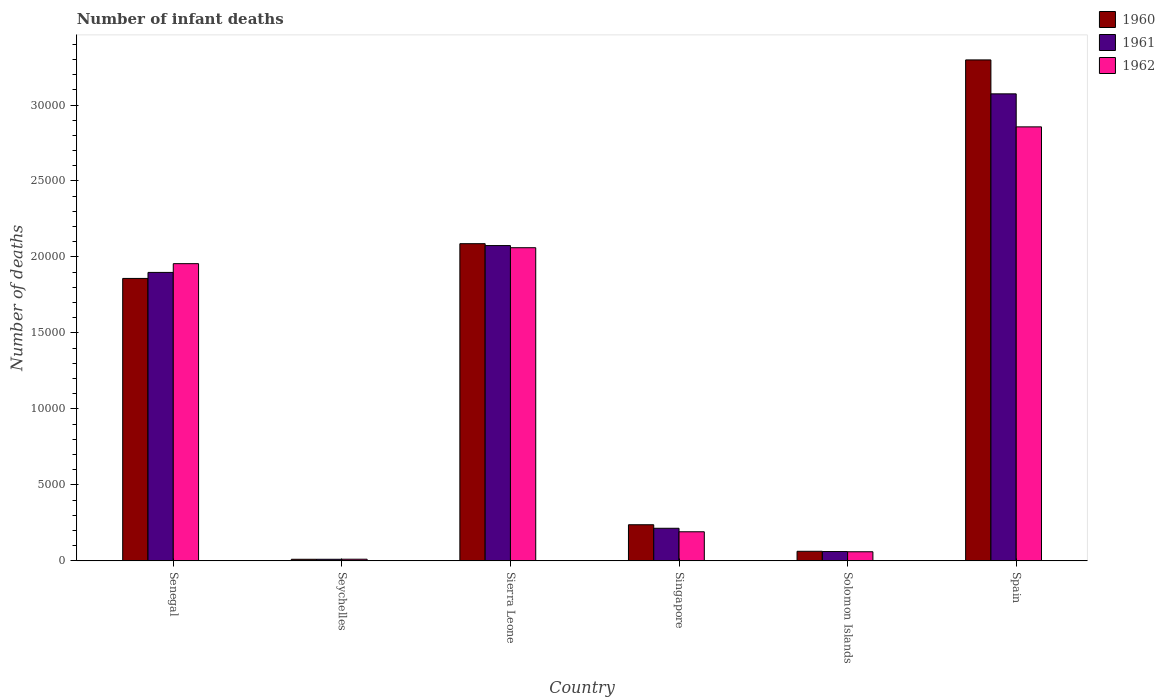How many groups of bars are there?
Offer a terse response. 6. How many bars are there on the 6th tick from the left?
Offer a very short reply. 3. How many bars are there on the 3rd tick from the right?
Your response must be concise. 3. What is the label of the 1st group of bars from the left?
Offer a terse response. Senegal. What is the number of infant deaths in 1962 in Senegal?
Ensure brevity in your answer.  1.96e+04. Across all countries, what is the maximum number of infant deaths in 1960?
Ensure brevity in your answer.  3.30e+04. Across all countries, what is the minimum number of infant deaths in 1960?
Keep it short and to the point. 102. In which country was the number of infant deaths in 1961 minimum?
Your answer should be very brief. Seychelles. What is the total number of infant deaths in 1961 in the graph?
Your answer should be very brief. 7.33e+04. What is the difference between the number of infant deaths in 1960 in Singapore and that in Spain?
Keep it short and to the point. -3.06e+04. What is the difference between the number of infant deaths in 1960 in Solomon Islands and the number of infant deaths in 1961 in Senegal?
Make the answer very short. -1.84e+04. What is the average number of infant deaths in 1962 per country?
Offer a very short reply. 1.19e+04. What is the difference between the number of infant deaths of/in 1961 and number of infant deaths of/in 1960 in Senegal?
Provide a short and direct response. 395. What is the ratio of the number of infant deaths in 1961 in Seychelles to that in Sierra Leone?
Offer a very short reply. 0. Is the number of infant deaths in 1961 in Sierra Leone less than that in Solomon Islands?
Keep it short and to the point. No. Is the difference between the number of infant deaths in 1961 in Sierra Leone and Singapore greater than the difference between the number of infant deaths in 1960 in Sierra Leone and Singapore?
Your answer should be compact. Yes. What is the difference between the highest and the second highest number of infant deaths in 1961?
Offer a very short reply. 1767. What is the difference between the highest and the lowest number of infant deaths in 1962?
Offer a terse response. 2.85e+04. What does the 1st bar from the right in Singapore represents?
Provide a short and direct response. 1962. How many bars are there?
Ensure brevity in your answer.  18. Are all the bars in the graph horizontal?
Keep it short and to the point. No. How many countries are there in the graph?
Your answer should be very brief. 6. Does the graph contain any zero values?
Provide a succinct answer. No. Does the graph contain grids?
Keep it short and to the point. No. Where does the legend appear in the graph?
Your answer should be compact. Top right. How many legend labels are there?
Offer a terse response. 3. How are the legend labels stacked?
Keep it short and to the point. Vertical. What is the title of the graph?
Ensure brevity in your answer.  Number of infant deaths. Does "1966" appear as one of the legend labels in the graph?
Provide a succinct answer. No. What is the label or title of the Y-axis?
Ensure brevity in your answer.  Number of deaths. What is the Number of deaths in 1960 in Senegal?
Make the answer very short. 1.86e+04. What is the Number of deaths of 1961 in Senegal?
Make the answer very short. 1.90e+04. What is the Number of deaths of 1962 in Senegal?
Make the answer very short. 1.96e+04. What is the Number of deaths of 1960 in Seychelles?
Your answer should be very brief. 102. What is the Number of deaths in 1961 in Seychelles?
Offer a terse response. 103. What is the Number of deaths in 1962 in Seychelles?
Your response must be concise. 107. What is the Number of deaths in 1960 in Sierra Leone?
Provide a short and direct response. 2.09e+04. What is the Number of deaths of 1961 in Sierra Leone?
Give a very brief answer. 2.07e+04. What is the Number of deaths of 1962 in Sierra Leone?
Your answer should be compact. 2.06e+04. What is the Number of deaths in 1960 in Singapore?
Your answer should be very brief. 2375. What is the Number of deaths of 1961 in Singapore?
Your response must be concise. 2143. What is the Number of deaths of 1962 in Singapore?
Give a very brief answer. 1912. What is the Number of deaths of 1960 in Solomon Islands?
Your answer should be very brief. 628. What is the Number of deaths in 1961 in Solomon Islands?
Provide a succinct answer. 612. What is the Number of deaths of 1962 in Solomon Islands?
Keep it short and to the point. 597. What is the Number of deaths of 1960 in Spain?
Your response must be concise. 3.30e+04. What is the Number of deaths of 1961 in Spain?
Provide a short and direct response. 3.07e+04. What is the Number of deaths of 1962 in Spain?
Give a very brief answer. 2.86e+04. Across all countries, what is the maximum Number of deaths in 1960?
Give a very brief answer. 3.30e+04. Across all countries, what is the maximum Number of deaths of 1961?
Make the answer very short. 3.07e+04. Across all countries, what is the maximum Number of deaths of 1962?
Offer a terse response. 2.86e+04. Across all countries, what is the minimum Number of deaths of 1960?
Give a very brief answer. 102. Across all countries, what is the minimum Number of deaths of 1961?
Keep it short and to the point. 103. Across all countries, what is the minimum Number of deaths in 1962?
Provide a short and direct response. 107. What is the total Number of deaths in 1960 in the graph?
Offer a very short reply. 7.55e+04. What is the total Number of deaths of 1961 in the graph?
Your answer should be compact. 7.33e+04. What is the total Number of deaths in 1962 in the graph?
Provide a short and direct response. 7.13e+04. What is the difference between the Number of deaths in 1960 in Senegal and that in Seychelles?
Your answer should be very brief. 1.85e+04. What is the difference between the Number of deaths in 1961 in Senegal and that in Seychelles?
Your answer should be compact. 1.89e+04. What is the difference between the Number of deaths in 1962 in Senegal and that in Seychelles?
Your answer should be compact. 1.95e+04. What is the difference between the Number of deaths in 1960 in Senegal and that in Sierra Leone?
Your answer should be compact. -2287. What is the difference between the Number of deaths in 1961 in Senegal and that in Sierra Leone?
Provide a short and direct response. -1767. What is the difference between the Number of deaths of 1962 in Senegal and that in Sierra Leone?
Offer a very short reply. -1050. What is the difference between the Number of deaths of 1960 in Senegal and that in Singapore?
Give a very brief answer. 1.62e+04. What is the difference between the Number of deaths in 1961 in Senegal and that in Singapore?
Keep it short and to the point. 1.68e+04. What is the difference between the Number of deaths of 1962 in Senegal and that in Singapore?
Offer a very short reply. 1.76e+04. What is the difference between the Number of deaths in 1960 in Senegal and that in Solomon Islands?
Keep it short and to the point. 1.80e+04. What is the difference between the Number of deaths in 1961 in Senegal and that in Solomon Islands?
Your response must be concise. 1.84e+04. What is the difference between the Number of deaths in 1962 in Senegal and that in Solomon Islands?
Offer a terse response. 1.90e+04. What is the difference between the Number of deaths in 1960 in Senegal and that in Spain?
Provide a short and direct response. -1.44e+04. What is the difference between the Number of deaths in 1961 in Senegal and that in Spain?
Your answer should be very brief. -1.18e+04. What is the difference between the Number of deaths in 1962 in Senegal and that in Spain?
Your response must be concise. -9004. What is the difference between the Number of deaths of 1960 in Seychelles and that in Sierra Leone?
Provide a short and direct response. -2.08e+04. What is the difference between the Number of deaths of 1961 in Seychelles and that in Sierra Leone?
Ensure brevity in your answer.  -2.06e+04. What is the difference between the Number of deaths in 1962 in Seychelles and that in Sierra Leone?
Your answer should be very brief. -2.05e+04. What is the difference between the Number of deaths of 1960 in Seychelles and that in Singapore?
Offer a terse response. -2273. What is the difference between the Number of deaths in 1961 in Seychelles and that in Singapore?
Ensure brevity in your answer.  -2040. What is the difference between the Number of deaths in 1962 in Seychelles and that in Singapore?
Keep it short and to the point. -1805. What is the difference between the Number of deaths of 1960 in Seychelles and that in Solomon Islands?
Ensure brevity in your answer.  -526. What is the difference between the Number of deaths in 1961 in Seychelles and that in Solomon Islands?
Offer a terse response. -509. What is the difference between the Number of deaths of 1962 in Seychelles and that in Solomon Islands?
Your answer should be very brief. -490. What is the difference between the Number of deaths in 1960 in Seychelles and that in Spain?
Your answer should be very brief. -3.29e+04. What is the difference between the Number of deaths in 1961 in Seychelles and that in Spain?
Offer a very short reply. -3.06e+04. What is the difference between the Number of deaths in 1962 in Seychelles and that in Spain?
Provide a short and direct response. -2.85e+04. What is the difference between the Number of deaths of 1960 in Sierra Leone and that in Singapore?
Ensure brevity in your answer.  1.85e+04. What is the difference between the Number of deaths of 1961 in Sierra Leone and that in Singapore?
Provide a short and direct response. 1.86e+04. What is the difference between the Number of deaths of 1962 in Sierra Leone and that in Singapore?
Offer a terse response. 1.87e+04. What is the difference between the Number of deaths in 1960 in Sierra Leone and that in Solomon Islands?
Make the answer very short. 2.02e+04. What is the difference between the Number of deaths of 1961 in Sierra Leone and that in Solomon Islands?
Your answer should be very brief. 2.01e+04. What is the difference between the Number of deaths of 1962 in Sierra Leone and that in Solomon Islands?
Make the answer very short. 2.00e+04. What is the difference between the Number of deaths in 1960 in Sierra Leone and that in Spain?
Offer a terse response. -1.21e+04. What is the difference between the Number of deaths of 1961 in Sierra Leone and that in Spain?
Your answer should be compact. -9986. What is the difference between the Number of deaths of 1962 in Sierra Leone and that in Spain?
Your answer should be very brief. -7954. What is the difference between the Number of deaths of 1960 in Singapore and that in Solomon Islands?
Give a very brief answer. 1747. What is the difference between the Number of deaths in 1961 in Singapore and that in Solomon Islands?
Offer a very short reply. 1531. What is the difference between the Number of deaths of 1962 in Singapore and that in Solomon Islands?
Keep it short and to the point. 1315. What is the difference between the Number of deaths of 1960 in Singapore and that in Spain?
Ensure brevity in your answer.  -3.06e+04. What is the difference between the Number of deaths of 1961 in Singapore and that in Spain?
Your response must be concise. -2.86e+04. What is the difference between the Number of deaths in 1962 in Singapore and that in Spain?
Offer a very short reply. -2.66e+04. What is the difference between the Number of deaths in 1960 in Solomon Islands and that in Spain?
Your answer should be compact. -3.23e+04. What is the difference between the Number of deaths in 1961 in Solomon Islands and that in Spain?
Your answer should be very brief. -3.01e+04. What is the difference between the Number of deaths in 1962 in Solomon Islands and that in Spain?
Offer a very short reply. -2.80e+04. What is the difference between the Number of deaths in 1960 in Senegal and the Number of deaths in 1961 in Seychelles?
Your answer should be compact. 1.85e+04. What is the difference between the Number of deaths of 1960 in Senegal and the Number of deaths of 1962 in Seychelles?
Your answer should be compact. 1.85e+04. What is the difference between the Number of deaths of 1961 in Senegal and the Number of deaths of 1962 in Seychelles?
Offer a very short reply. 1.89e+04. What is the difference between the Number of deaths in 1960 in Senegal and the Number of deaths in 1961 in Sierra Leone?
Give a very brief answer. -2162. What is the difference between the Number of deaths in 1960 in Senegal and the Number of deaths in 1962 in Sierra Leone?
Offer a terse response. -2021. What is the difference between the Number of deaths in 1961 in Senegal and the Number of deaths in 1962 in Sierra Leone?
Your answer should be very brief. -1626. What is the difference between the Number of deaths of 1960 in Senegal and the Number of deaths of 1961 in Singapore?
Your answer should be compact. 1.64e+04. What is the difference between the Number of deaths of 1960 in Senegal and the Number of deaths of 1962 in Singapore?
Your response must be concise. 1.67e+04. What is the difference between the Number of deaths of 1961 in Senegal and the Number of deaths of 1962 in Singapore?
Offer a terse response. 1.71e+04. What is the difference between the Number of deaths in 1960 in Senegal and the Number of deaths in 1961 in Solomon Islands?
Your answer should be very brief. 1.80e+04. What is the difference between the Number of deaths of 1960 in Senegal and the Number of deaths of 1962 in Solomon Islands?
Provide a succinct answer. 1.80e+04. What is the difference between the Number of deaths in 1961 in Senegal and the Number of deaths in 1962 in Solomon Islands?
Provide a succinct answer. 1.84e+04. What is the difference between the Number of deaths in 1960 in Senegal and the Number of deaths in 1961 in Spain?
Give a very brief answer. -1.21e+04. What is the difference between the Number of deaths in 1960 in Senegal and the Number of deaths in 1962 in Spain?
Offer a very short reply. -9975. What is the difference between the Number of deaths of 1961 in Senegal and the Number of deaths of 1962 in Spain?
Keep it short and to the point. -9580. What is the difference between the Number of deaths of 1960 in Seychelles and the Number of deaths of 1961 in Sierra Leone?
Your response must be concise. -2.06e+04. What is the difference between the Number of deaths of 1960 in Seychelles and the Number of deaths of 1962 in Sierra Leone?
Ensure brevity in your answer.  -2.05e+04. What is the difference between the Number of deaths of 1961 in Seychelles and the Number of deaths of 1962 in Sierra Leone?
Offer a terse response. -2.05e+04. What is the difference between the Number of deaths in 1960 in Seychelles and the Number of deaths in 1961 in Singapore?
Provide a succinct answer. -2041. What is the difference between the Number of deaths of 1960 in Seychelles and the Number of deaths of 1962 in Singapore?
Offer a terse response. -1810. What is the difference between the Number of deaths in 1961 in Seychelles and the Number of deaths in 1962 in Singapore?
Your response must be concise. -1809. What is the difference between the Number of deaths in 1960 in Seychelles and the Number of deaths in 1961 in Solomon Islands?
Your answer should be compact. -510. What is the difference between the Number of deaths of 1960 in Seychelles and the Number of deaths of 1962 in Solomon Islands?
Keep it short and to the point. -495. What is the difference between the Number of deaths in 1961 in Seychelles and the Number of deaths in 1962 in Solomon Islands?
Your answer should be very brief. -494. What is the difference between the Number of deaths of 1960 in Seychelles and the Number of deaths of 1961 in Spain?
Your response must be concise. -3.06e+04. What is the difference between the Number of deaths of 1960 in Seychelles and the Number of deaths of 1962 in Spain?
Your response must be concise. -2.85e+04. What is the difference between the Number of deaths in 1961 in Seychelles and the Number of deaths in 1962 in Spain?
Give a very brief answer. -2.85e+04. What is the difference between the Number of deaths in 1960 in Sierra Leone and the Number of deaths in 1961 in Singapore?
Keep it short and to the point. 1.87e+04. What is the difference between the Number of deaths of 1960 in Sierra Leone and the Number of deaths of 1962 in Singapore?
Provide a short and direct response. 1.90e+04. What is the difference between the Number of deaths in 1961 in Sierra Leone and the Number of deaths in 1962 in Singapore?
Give a very brief answer. 1.88e+04. What is the difference between the Number of deaths in 1960 in Sierra Leone and the Number of deaths in 1961 in Solomon Islands?
Provide a short and direct response. 2.03e+04. What is the difference between the Number of deaths in 1960 in Sierra Leone and the Number of deaths in 1962 in Solomon Islands?
Keep it short and to the point. 2.03e+04. What is the difference between the Number of deaths of 1961 in Sierra Leone and the Number of deaths of 1962 in Solomon Islands?
Your answer should be very brief. 2.02e+04. What is the difference between the Number of deaths of 1960 in Sierra Leone and the Number of deaths of 1961 in Spain?
Your response must be concise. -9861. What is the difference between the Number of deaths of 1960 in Sierra Leone and the Number of deaths of 1962 in Spain?
Provide a short and direct response. -7688. What is the difference between the Number of deaths in 1961 in Sierra Leone and the Number of deaths in 1962 in Spain?
Ensure brevity in your answer.  -7813. What is the difference between the Number of deaths in 1960 in Singapore and the Number of deaths in 1961 in Solomon Islands?
Provide a short and direct response. 1763. What is the difference between the Number of deaths of 1960 in Singapore and the Number of deaths of 1962 in Solomon Islands?
Your response must be concise. 1778. What is the difference between the Number of deaths in 1961 in Singapore and the Number of deaths in 1962 in Solomon Islands?
Your answer should be compact. 1546. What is the difference between the Number of deaths in 1960 in Singapore and the Number of deaths in 1961 in Spain?
Give a very brief answer. -2.84e+04. What is the difference between the Number of deaths in 1960 in Singapore and the Number of deaths in 1962 in Spain?
Provide a succinct answer. -2.62e+04. What is the difference between the Number of deaths of 1961 in Singapore and the Number of deaths of 1962 in Spain?
Provide a succinct answer. -2.64e+04. What is the difference between the Number of deaths of 1960 in Solomon Islands and the Number of deaths of 1961 in Spain?
Keep it short and to the point. -3.01e+04. What is the difference between the Number of deaths in 1960 in Solomon Islands and the Number of deaths in 1962 in Spain?
Provide a succinct answer. -2.79e+04. What is the difference between the Number of deaths in 1961 in Solomon Islands and the Number of deaths in 1962 in Spain?
Your answer should be very brief. -2.80e+04. What is the average Number of deaths of 1960 per country?
Give a very brief answer. 1.26e+04. What is the average Number of deaths of 1961 per country?
Your response must be concise. 1.22e+04. What is the average Number of deaths in 1962 per country?
Your response must be concise. 1.19e+04. What is the difference between the Number of deaths of 1960 and Number of deaths of 1961 in Senegal?
Your answer should be very brief. -395. What is the difference between the Number of deaths of 1960 and Number of deaths of 1962 in Senegal?
Provide a short and direct response. -971. What is the difference between the Number of deaths of 1961 and Number of deaths of 1962 in Senegal?
Your answer should be very brief. -576. What is the difference between the Number of deaths in 1960 and Number of deaths in 1961 in Sierra Leone?
Offer a terse response. 125. What is the difference between the Number of deaths in 1960 and Number of deaths in 1962 in Sierra Leone?
Your answer should be very brief. 266. What is the difference between the Number of deaths of 1961 and Number of deaths of 1962 in Sierra Leone?
Make the answer very short. 141. What is the difference between the Number of deaths of 1960 and Number of deaths of 1961 in Singapore?
Your answer should be compact. 232. What is the difference between the Number of deaths in 1960 and Number of deaths in 1962 in Singapore?
Make the answer very short. 463. What is the difference between the Number of deaths in 1961 and Number of deaths in 1962 in Singapore?
Give a very brief answer. 231. What is the difference between the Number of deaths in 1960 and Number of deaths in 1962 in Solomon Islands?
Your answer should be compact. 31. What is the difference between the Number of deaths of 1960 and Number of deaths of 1961 in Spain?
Your answer should be very brief. 2233. What is the difference between the Number of deaths of 1960 and Number of deaths of 1962 in Spain?
Give a very brief answer. 4406. What is the difference between the Number of deaths of 1961 and Number of deaths of 1962 in Spain?
Your answer should be very brief. 2173. What is the ratio of the Number of deaths in 1960 in Senegal to that in Seychelles?
Your answer should be compact. 182.23. What is the ratio of the Number of deaths in 1961 in Senegal to that in Seychelles?
Offer a terse response. 184.29. What is the ratio of the Number of deaths in 1962 in Senegal to that in Seychelles?
Your response must be concise. 182.78. What is the ratio of the Number of deaths in 1960 in Senegal to that in Sierra Leone?
Provide a succinct answer. 0.89. What is the ratio of the Number of deaths in 1961 in Senegal to that in Sierra Leone?
Keep it short and to the point. 0.91. What is the ratio of the Number of deaths of 1962 in Senegal to that in Sierra Leone?
Provide a succinct answer. 0.95. What is the ratio of the Number of deaths of 1960 in Senegal to that in Singapore?
Offer a very short reply. 7.83. What is the ratio of the Number of deaths of 1961 in Senegal to that in Singapore?
Your answer should be compact. 8.86. What is the ratio of the Number of deaths of 1962 in Senegal to that in Singapore?
Provide a succinct answer. 10.23. What is the ratio of the Number of deaths of 1960 in Senegal to that in Solomon Islands?
Give a very brief answer. 29.6. What is the ratio of the Number of deaths in 1961 in Senegal to that in Solomon Islands?
Provide a succinct answer. 31.02. What is the ratio of the Number of deaths in 1962 in Senegal to that in Solomon Islands?
Your response must be concise. 32.76. What is the ratio of the Number of deaths of 1960 in Senegal to that in Spain?
Your response must be concise. 0.56. What is the ratio of the Number of deaths in 1961 in Senegal to that in Spain?
Give a very brief answer. 0.62. What is the ratio of the Number of deaths of 1962 in Senegal to that in Spain?
Make the answer very short. 0.68. What is the ratio of the Number of deaths of 1960 in Seychelles to that in Sierra Leone?
Offer a very short reply. 0. What is the ratio of the Number of deaths in 1961 in Seychelles to that in Sierra Leone?
Offer a very short reply. 0.01. What is the ratio of the Number of deaths of 1962 in Seychelles to that in Sierra Leone?
Provide a succinct answer. 0.01. What is the ratio of the Number of deaths of 1960 in Seychelles to that in Singapore?
Ensure brevity in your answer.  0.04. What is the ratio of the Number of deaths of 1961 in Seychelles to that in Singapore?
Your response must be concise. 0.05. What is the ratio of the Number of deaths of 1962 in Seychelles to that in Singapore?
Provide a short and direct response. 0.06. What is the ratio of the Number of deaths of 1960 in Seychelles to that in Solomon Islands?
Your answer should be very brief. 0.16. What is the ratio of the Number of deaths in 1961 in Seychelles to that in Solomon Islands?
Ensure brevity in your answer.  0.17. What is the ratio of the Number of deaths of 1962 in Seychelles to that in Solomon Islands?
Make the answer very short. 0.18. What is the ratio of the Number of deaths of 1960 in Seychelles to that in Spain?
Provide a succinct answer. 0. What is the ratio of the Number of deaths in 1961 in Seychelles to that in Spain?
Provide a short and direct response. 0. What is the ratio of the Number of deaths in 1962 in Seychelles to that in Spain?
Keep it short and to the point. 0. What is the ratio of the Number of deaths in 1960 in Sierra Leone to that in Singapore?
Provide a short and direct response. 8.79. What is the ratio of the Number of deaths in 1961 in Sierra Leone to that in Singapore?
Keep it short and to the point. 9.68. What is the ratio of the Number of deaths in 1962 in Sierra Leone to that in Singapore?
Your answer should be very brief. 10.78. What is the ratio of the Number of deaths of 1960 in Sierra Leone to that in Solomon Islands?
Your answer should be very brief. 33.24. What is the ratio of the Number of deaths of 1961 in Sierra Leone to that in Solomon Islands?
Make the answer very short. 33.9. What is the ratio of the Number of deaths in 1962 in Sierra Leone to that in Solomon Islands?
Give a very brief answer. 34.52. What is the ratio of the Number of deaths in 1960 in Sierra Leone to that in Spain?
Your response must be concise. 0.63. What is the ratio of the Number of deaths of 1961 in Sierra Leone to that in Spain?
Your response must be concise. 0.68. What is the ratio of the Number of deaths in 1962 in Sierra Leone to that in Spain?
Provide a succinct answer. 0.72. What is the ratio of the Number of deaths in 1960 in Singapore to that in Solomon Islands?
Give a very brief answer. 3.78. What is the ratio of the Number of deaths of 1961 in Singapore to that in Solomon Islands?
Provide a short and direct response. 3.5. What is the ratio of the Number of deaths of 1962 in Singapore to that in Solomon Islands?
Keep it short and to the point. 3.2. What is the ratio of the Number of deaths in 1960 in Singapore to that in Spain?
Keep it short and to the point. 0.07. What is the ratio of the Number of deaths of 1961 in Singapore to that in Spain?
Offer a terse response. 0.07. What is the ratio of the Number of deaths in 1962 in Singapore to that in Spain?
Make the answer very short. 0.07. What is the ratio of the Number of deaths of 1960 in Solomon Islands to that in Spain?
Offer a terse response. 0.02. What is the ratio of the Number of deaths in 1961 in Solomon Islands to that in Spain?
Provide a short and direct response. 0.02. What is the ratio of the Number of deaths of 1962 in Solomon Islands to that in Spain?
Your answer should be compact. 0.02. What is the difference between the highest and the second highest Number of deaths of 1960?
Offer a very short reply. 1.21e+04. What is the difference between the highest and the second highest Number of deaths of 1961?
Keep it short and to the point. 9986. What is the difference between the highest and the second highest Number of deaths in 1962?
Keep it short and to the point. 7954. What is the difference between the highest and the lowest Number of deaths of 1960?
Your answer should be very brief. 3.29e+04. What is the difference between the highest and the lowest Number of deaths of 1961?
Offer a terse response. 3.06e+04. What is the difference between the highest and the lowest Number of deaths in 1962?
Make the answer very short. 2.85e+04. 